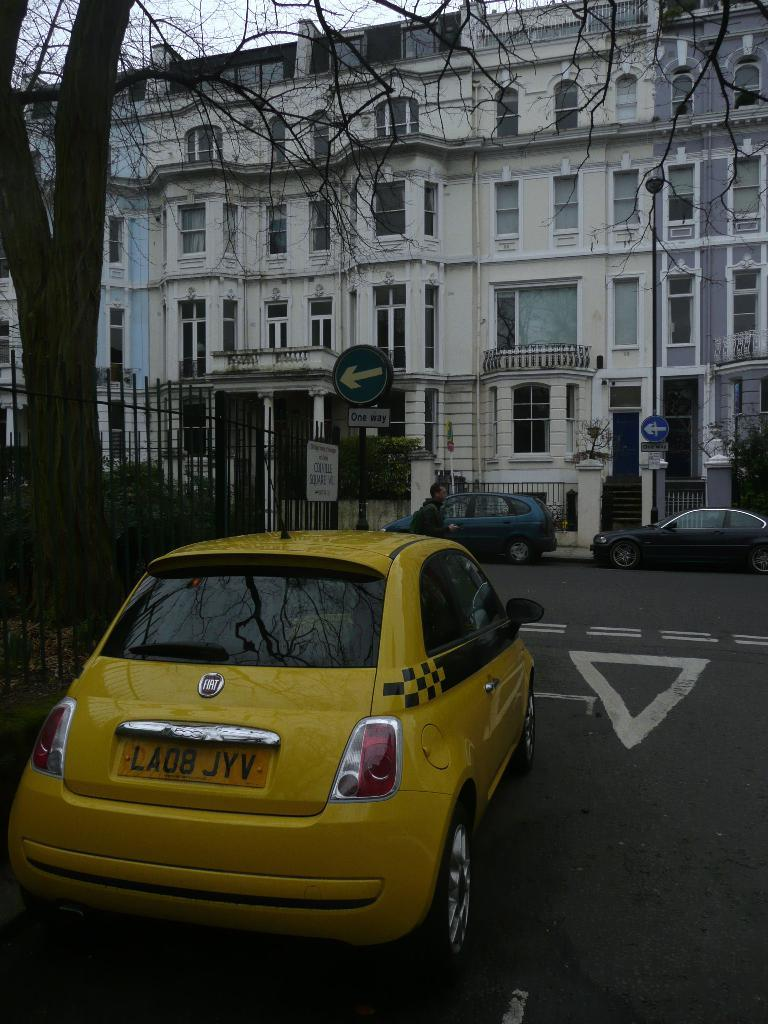<image>
Relay a brief, clear account of the picture shown. A yellow taxi cab has LA08 JYV for a license plate number. 